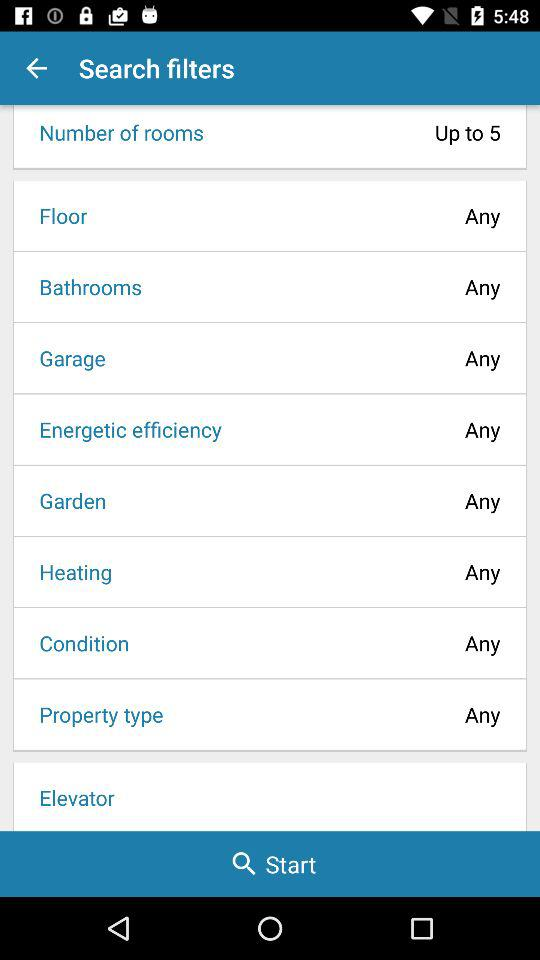What is the selected property type? The selected property type is "Any". 